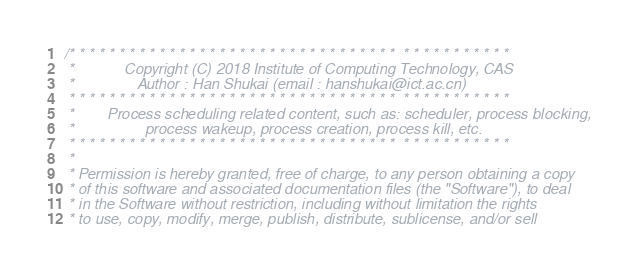Convert code to text. <code><loc_0><loc_0><loc_500><loc_500><_C_>/* * * * * * * * * * * * * * * * * * * * * * * * * * * * * * * * *  * * * * * * * * * * *
 *            Copyright (C) 2018 Institute of Computing Technology, CAS
 *               Author : Han Shukai (email : hanshukai@ict.ac.cn)
 * * * * * * * * * * * * * * * * * * * * * * * * * * * * * * * * *  * * * * * * * * * * *
 *        Process scheduling related content, such as: scheduler, process blocking, 
 *                 process wakeup, process creation, process kill, etc.
 * * * * * * * * * * * * * * * * * * * * * * * * * * * * * * * * *  * * * * * * * * * * *
 * 
 * Permission is hereby granted, free of charge, to any person obtaining a copy
 * of this software and associated documentation files (the "Software"), to deal
 * in the Software without restriction, including without limitation the rights
 * to use, copy, modify, merge, publish, distribute, sublicense, and/or sell</code> 